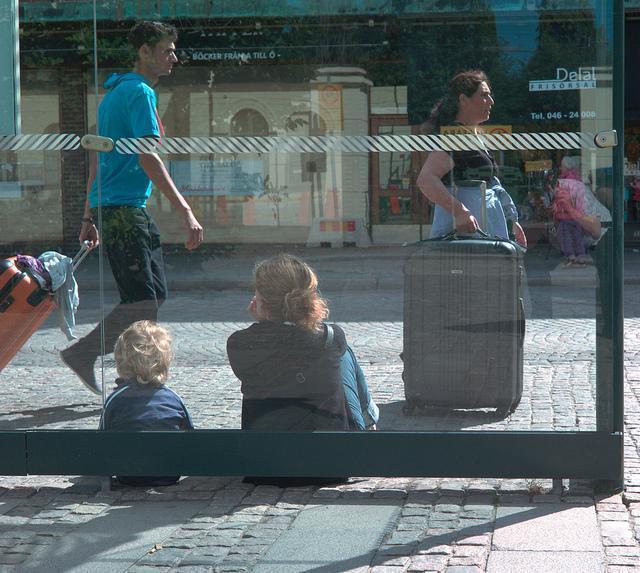Why is the white lines on the glass?
Select the correct answer and articulate reasoning with the following format: 'Answer: answer
Rationale: rationale.'
Options: Visibility, height restriction, decoration, measurement. Answer: visibility.
Rationale: The white lines are to increase visibility on the translucent glass preventing people or birds from colliding into it. 